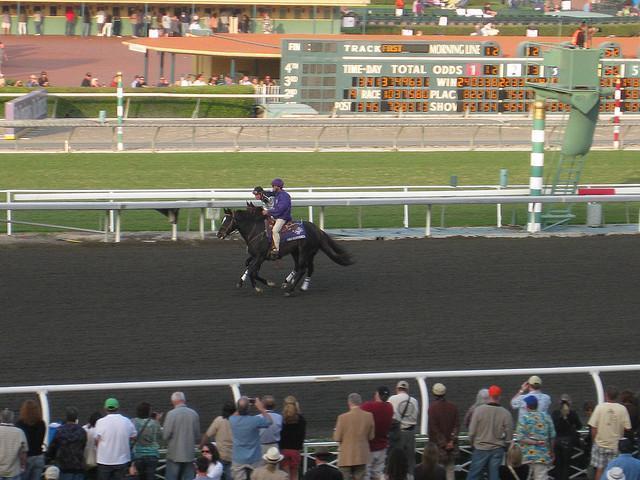What type of event is being held?
Make your selection from the four choices given to correctly answer the question.
Options: Play, race, concert, parade. Race. 